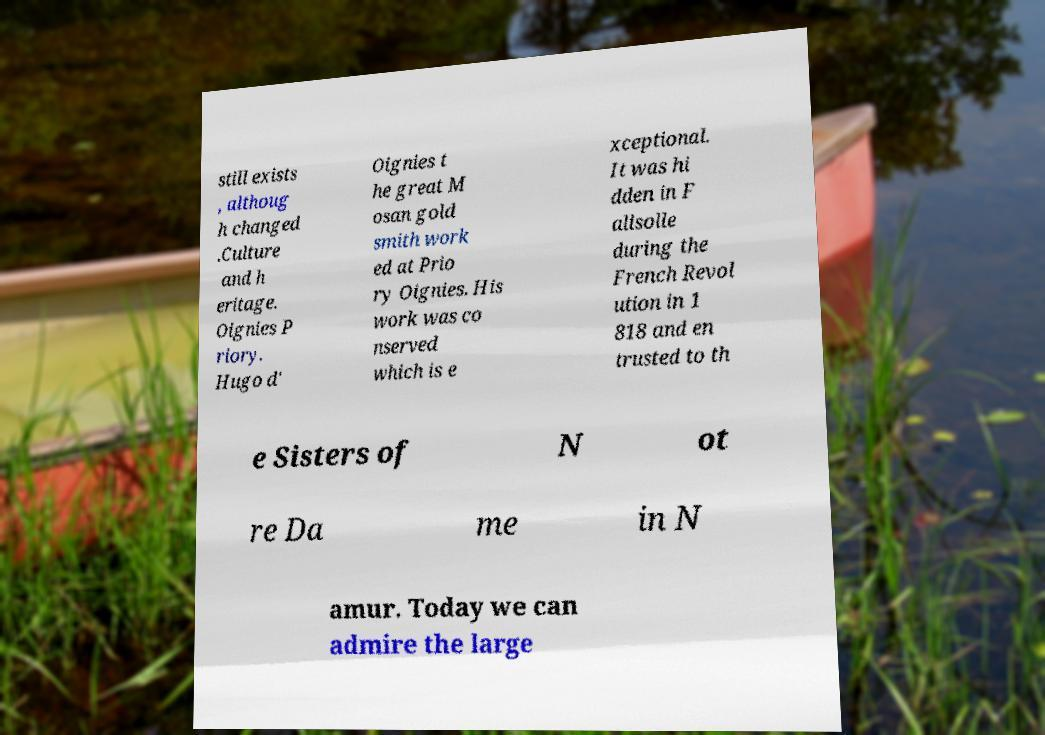What messages or text are displayed in this image? I need them in a readable, typed format. still exists , althoug h changed .Culture and h eritage. Oignies P riory. Hugo d' Oignies t he great M osan gold smith work ed at Prio ry Oignies. His work was co nserved which is e xceptional. It was hi dden in F alisolle during the French Revol ution in 1 818 and en trusted to th e Sisters of N ot re Da me in N amur. Today we can admire the large 